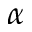Convert formula to latex. <formula><loc_0><loc_0><loc_500><loc_500>\alpha</formula> 